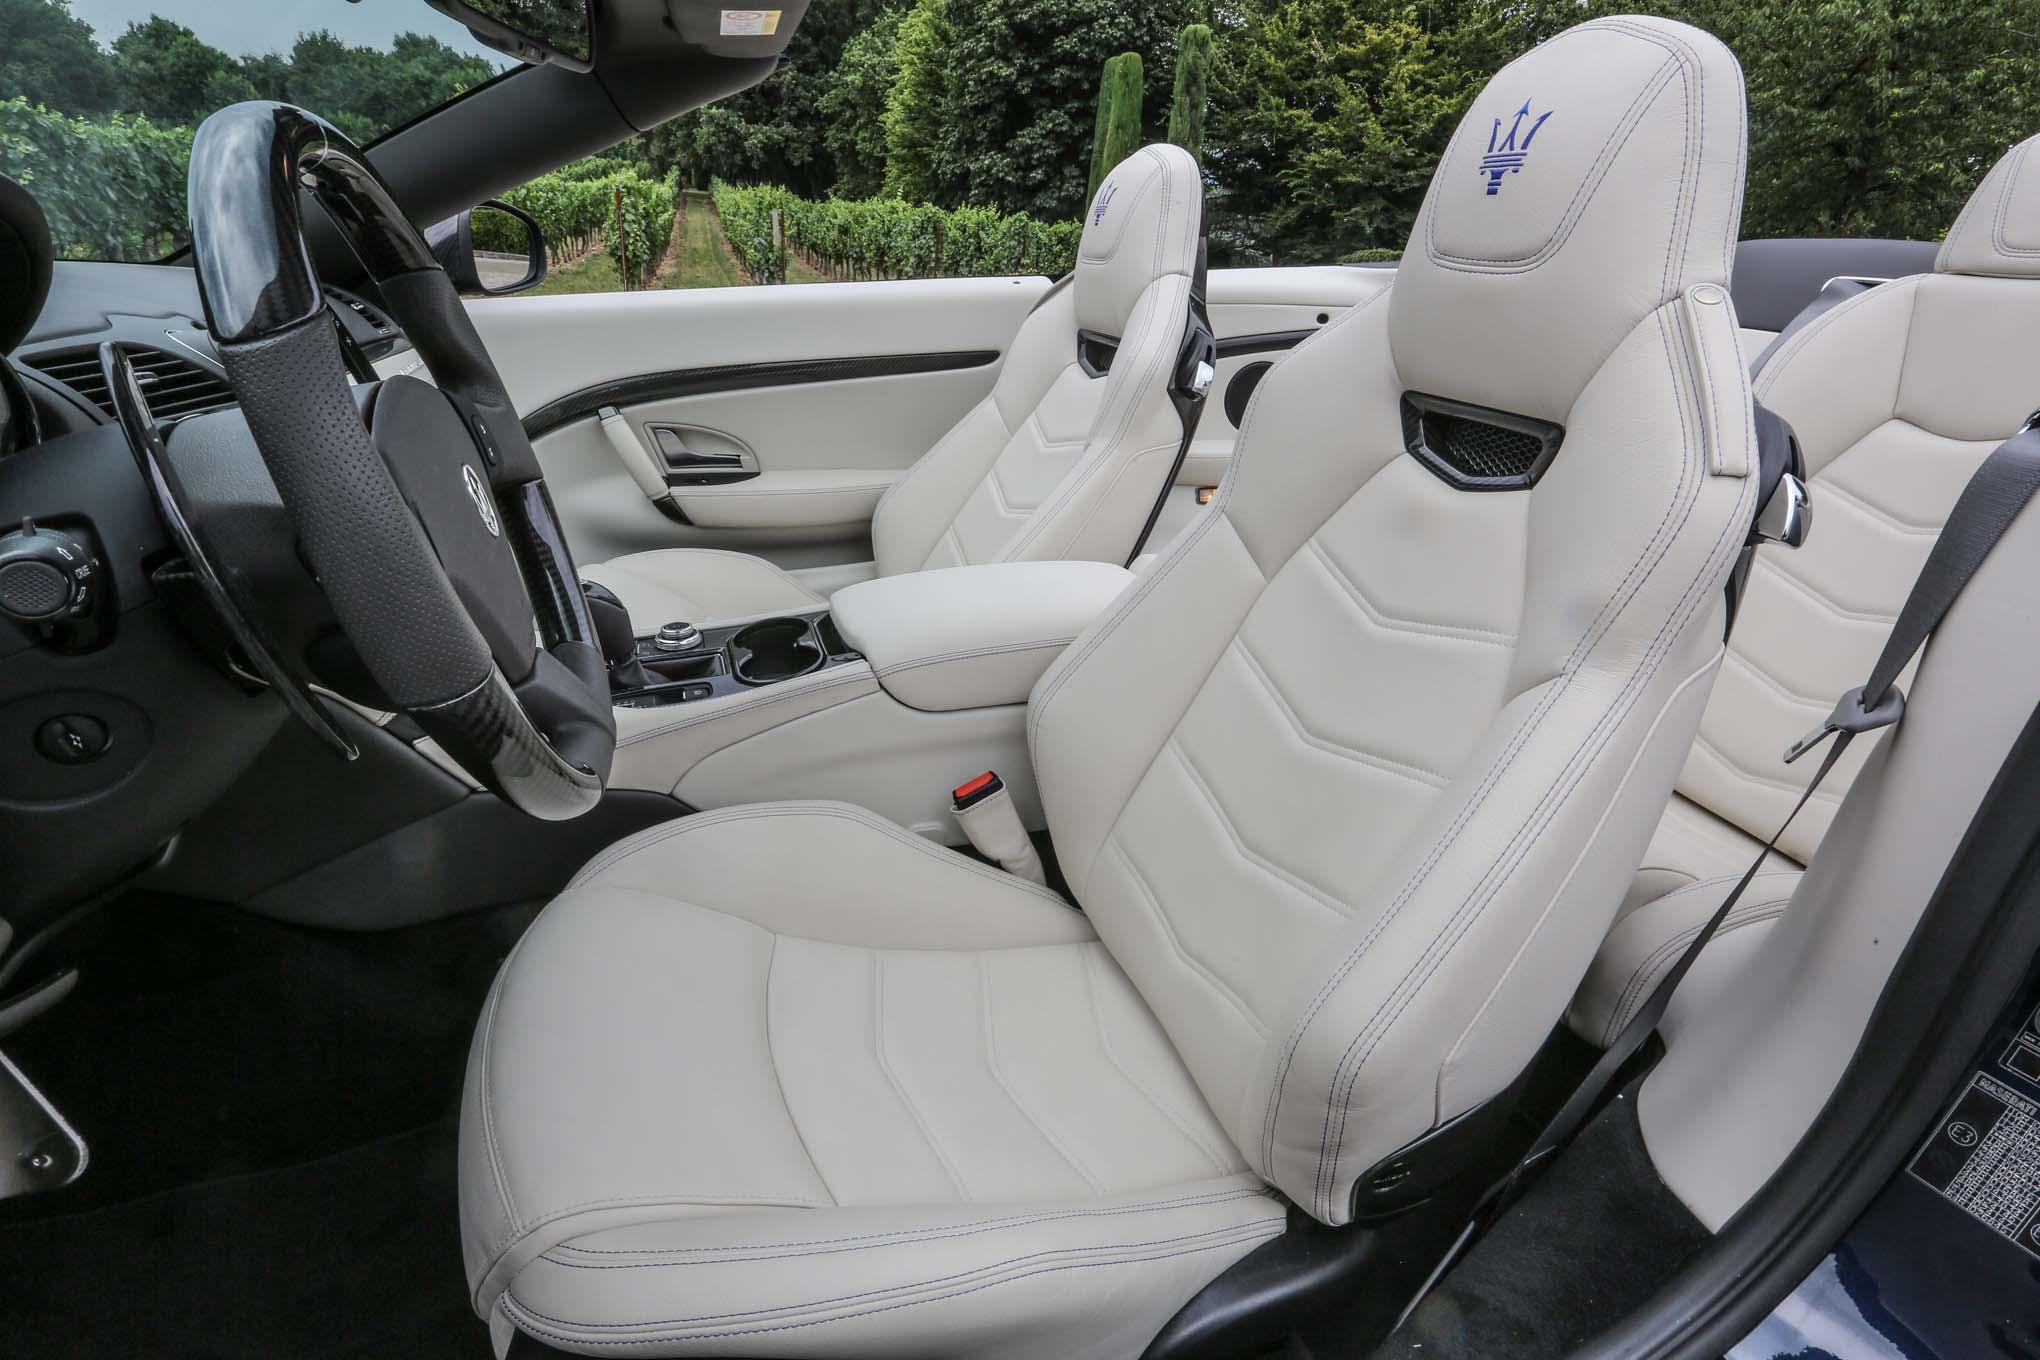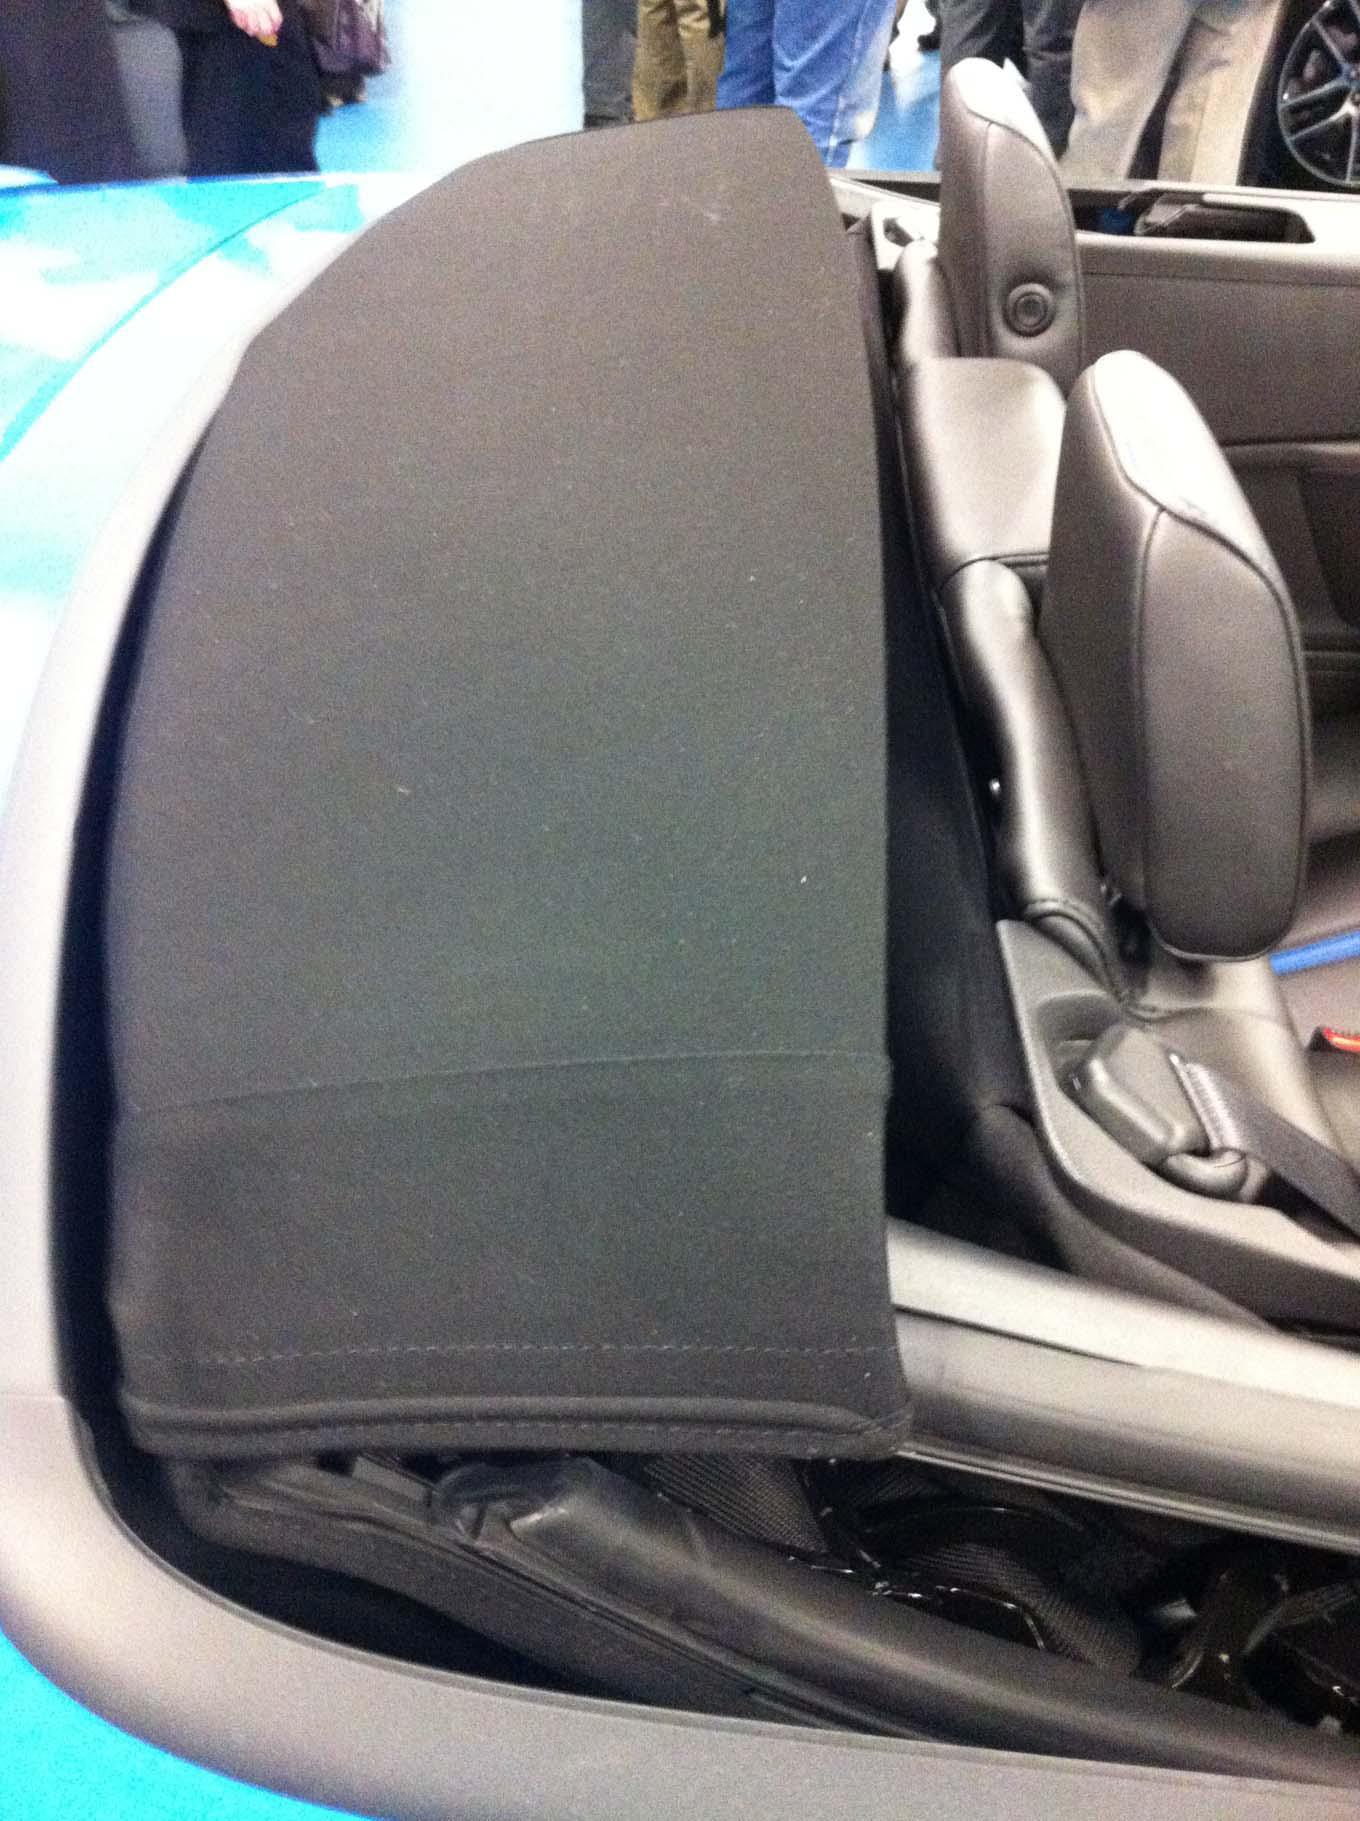The first image is the image on the left, the second image is the image on the right. Assess this claim about the two images: "Both images show shiny painted exteriors of antique convertibles in good condition.". Correct or not? Answer yes or no. No. The first image is the image on the left, the second image is the image on the right. For the images shown, is this caption "There are multiple cars behind a parked classic car in one of the images." true? Answer yes or no. No. 